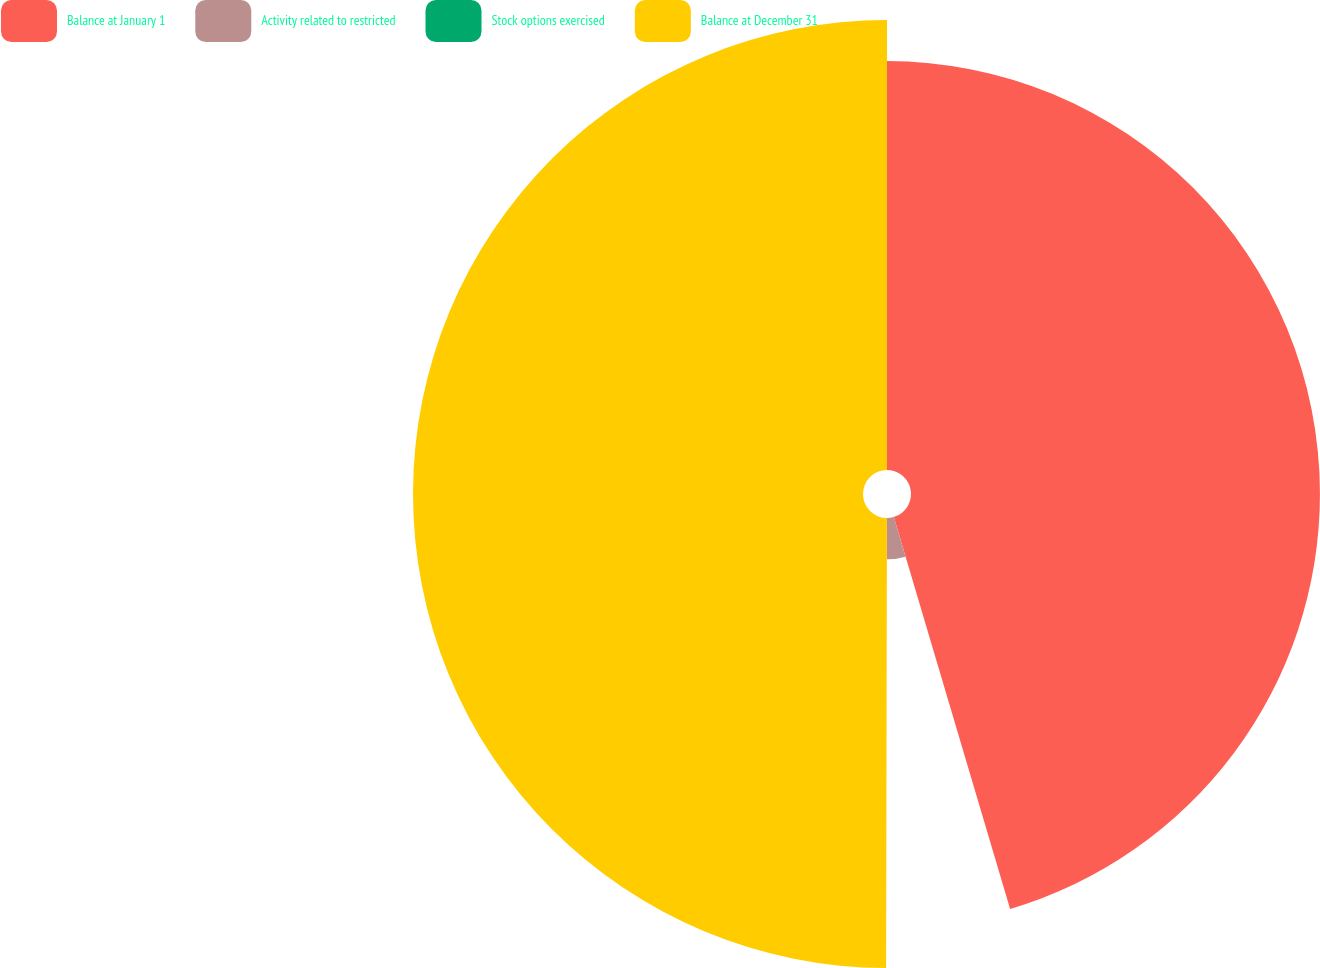Convert chart to OTSL. <chart><loc_0><loc_0><loc_500><loc_500><pie_chart><fcel>Balance at January 1<fcel>Activity related to restricted<fcel>Stock options exercised<fcel>Balance at December 31<nl><fcel>45.41%<fcel>4.59%<fcel>0.03%<fcel>49.97%<nl></chart> 